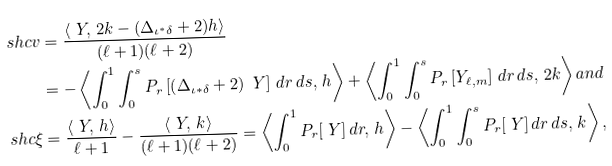<formula> <loc_0><loc_0><loc_500><loc_500>\ s h c { v } & = \frac { \left \langle \ Y , \, 2 k - ( \Delta _ { \iota ^ { * } \delta } + 2 ) h \right \rangle } { ( \ell + 1 ) ( \ell + 2 ) } \\ & = - \left \langle \int _ { 0 } ^ { 1 } \int _ { 0 } ^ { s } P _ { r } \left [ \left ( \Delta _ { \iota * \delta } + 2 \right ) \ Y \right ] \, d r \, d s , \, h \right \rangle + \left \langle \int _ { 0 } ^ { 1 } \int _ { 0 } ^ { s } P _ { r } \left [ Y _ { \ell , m } \right ] \, d r \, d s , \, 2 k \right \rangle a n d \\ \ s h c { \xi } & = \frac { \left \langle \ Y , \, h \right \rangle } { \ell + 1 } - \frac { \left \langle \ Y , \, k \right \rangle } { ( \ell + 1 ) ( \ell + 2 ) } = \left \langle \int _ { 0 } ^ { 1 } P _ { r } [ \ Y ] \, d r , \, h \right \rangle - \left \langle \int _ { 0 } ^ { 1 } \int _ { 0 } ^ { s } P _ { r } [ \ Y ] \, d r \, d s , \, k \right \rangle ,</formula> 